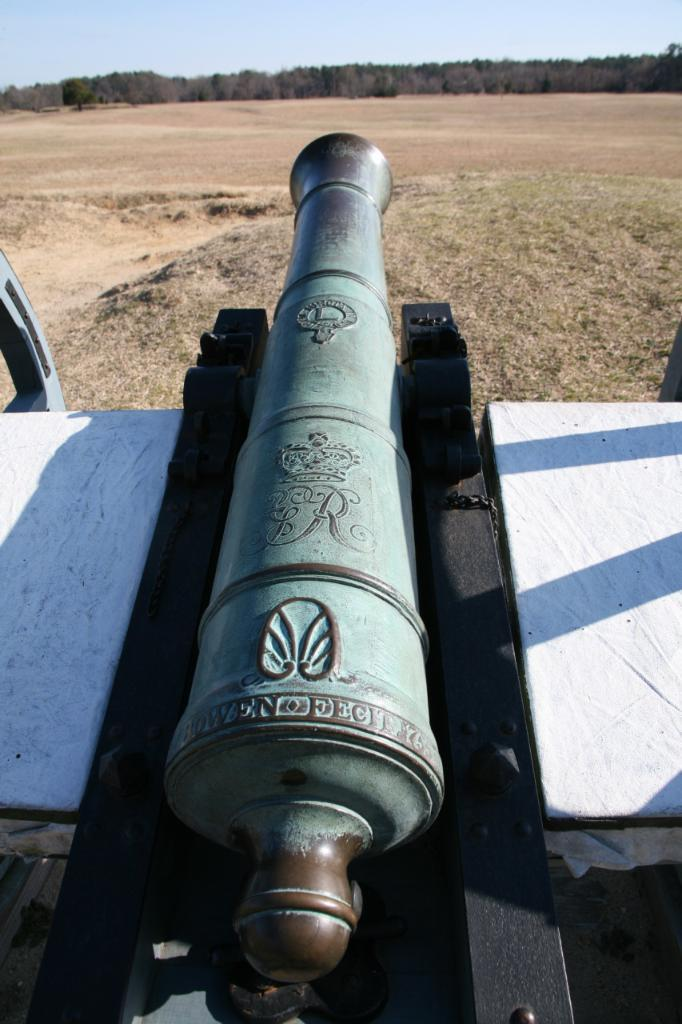What is the main object located at the bottom of the picture? There is a cannon at the bottom of the picture. What can be seen in the background of the picture? There are trees in the background of the picture. What is visible at the top of the picture? The sky is visible at the top of the picture. What type of grape is being played in the morning in the picture? There is no grape or music present in the picture, and no indication of time of day. 